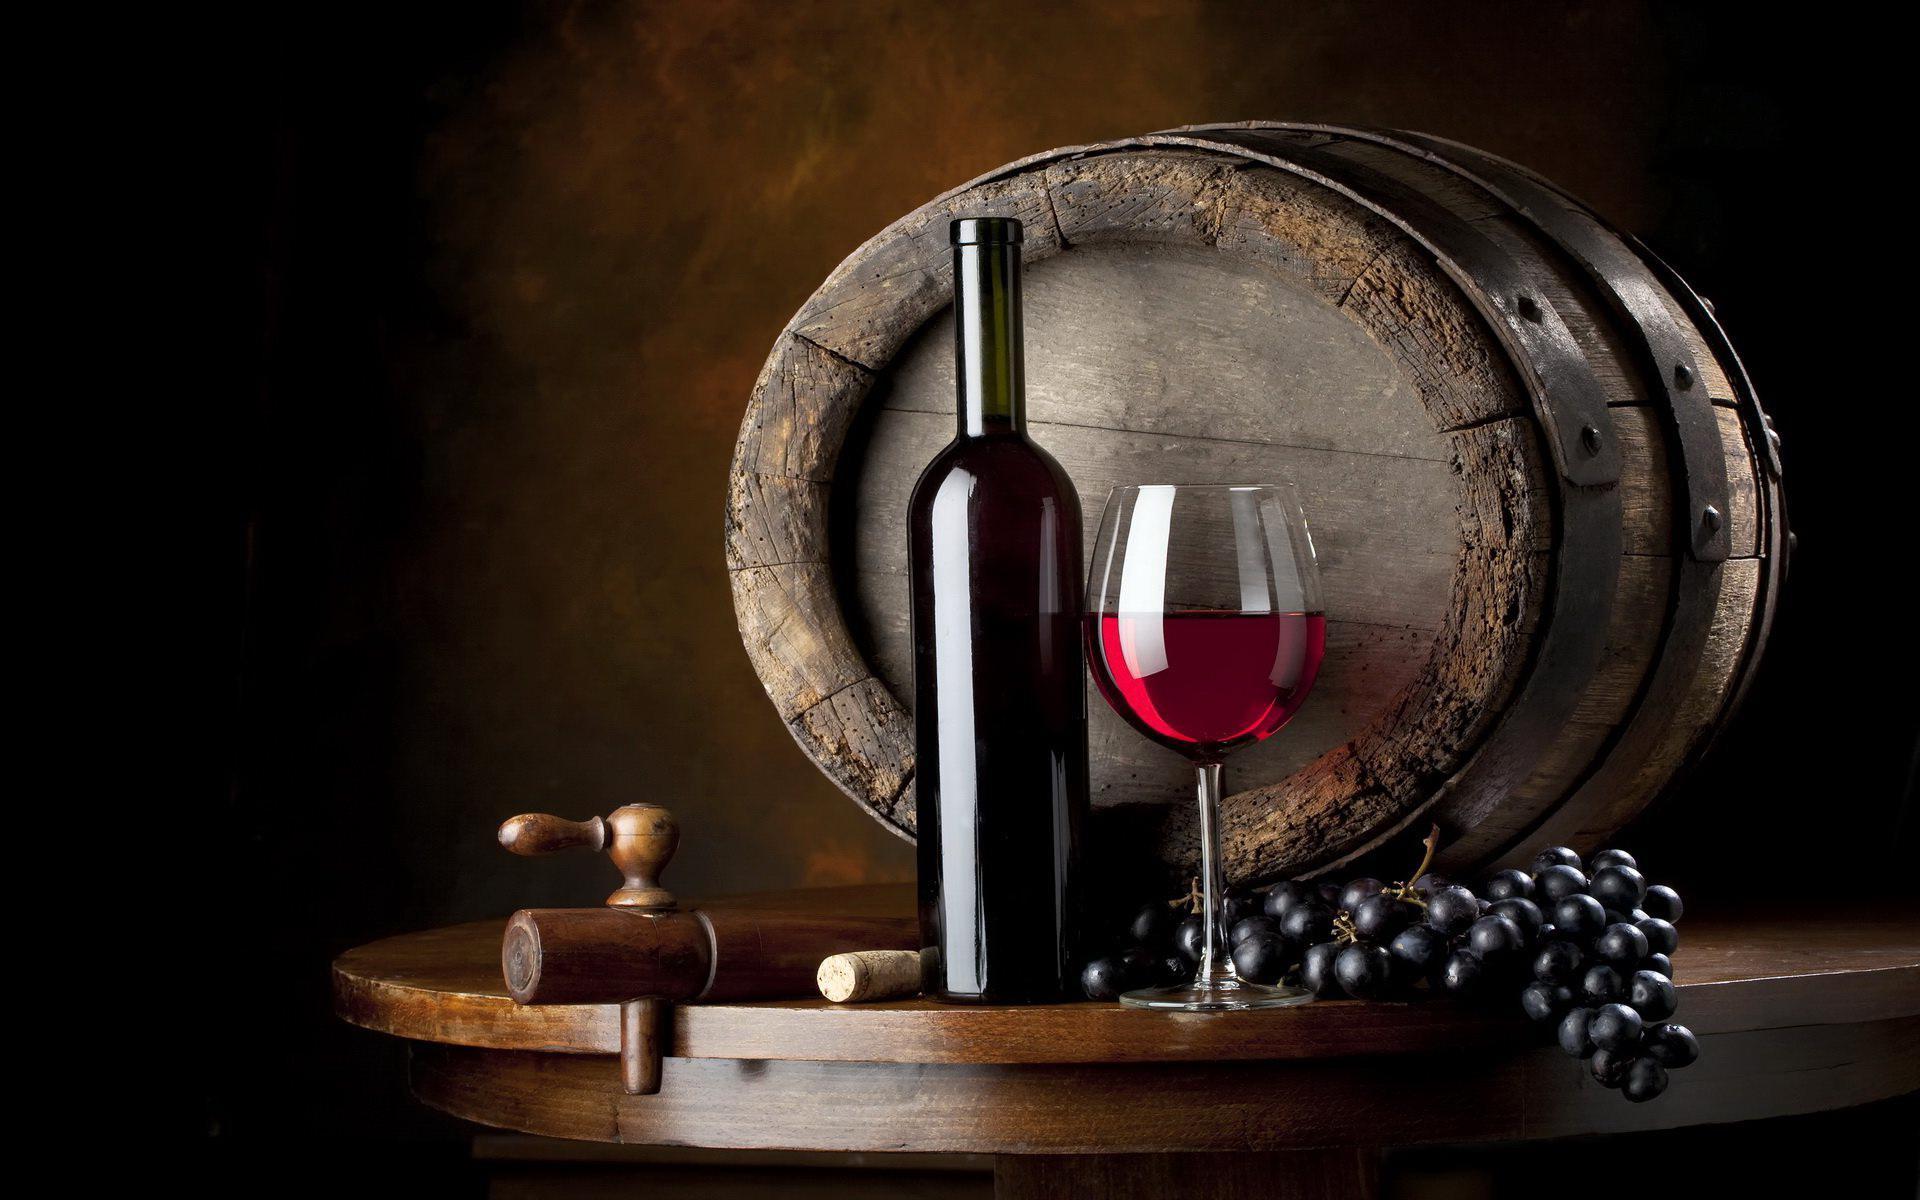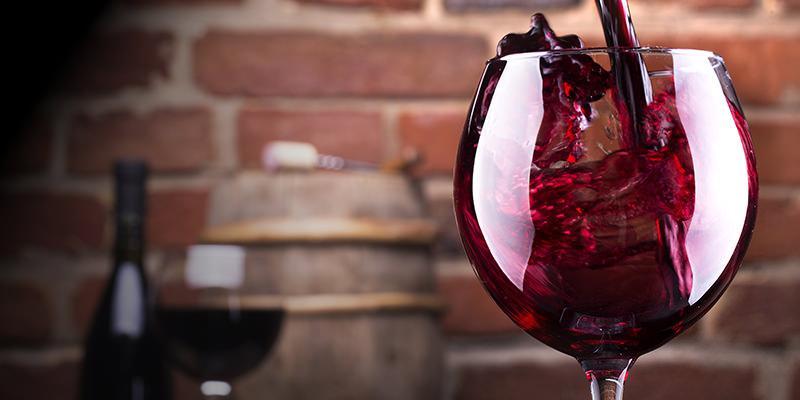The first image is the image on the left, the second image is the image on the right. Considering the images on both sides, is "The left image shows burgundy wine pouring into a glass." valid? Answer yes or no. No. 